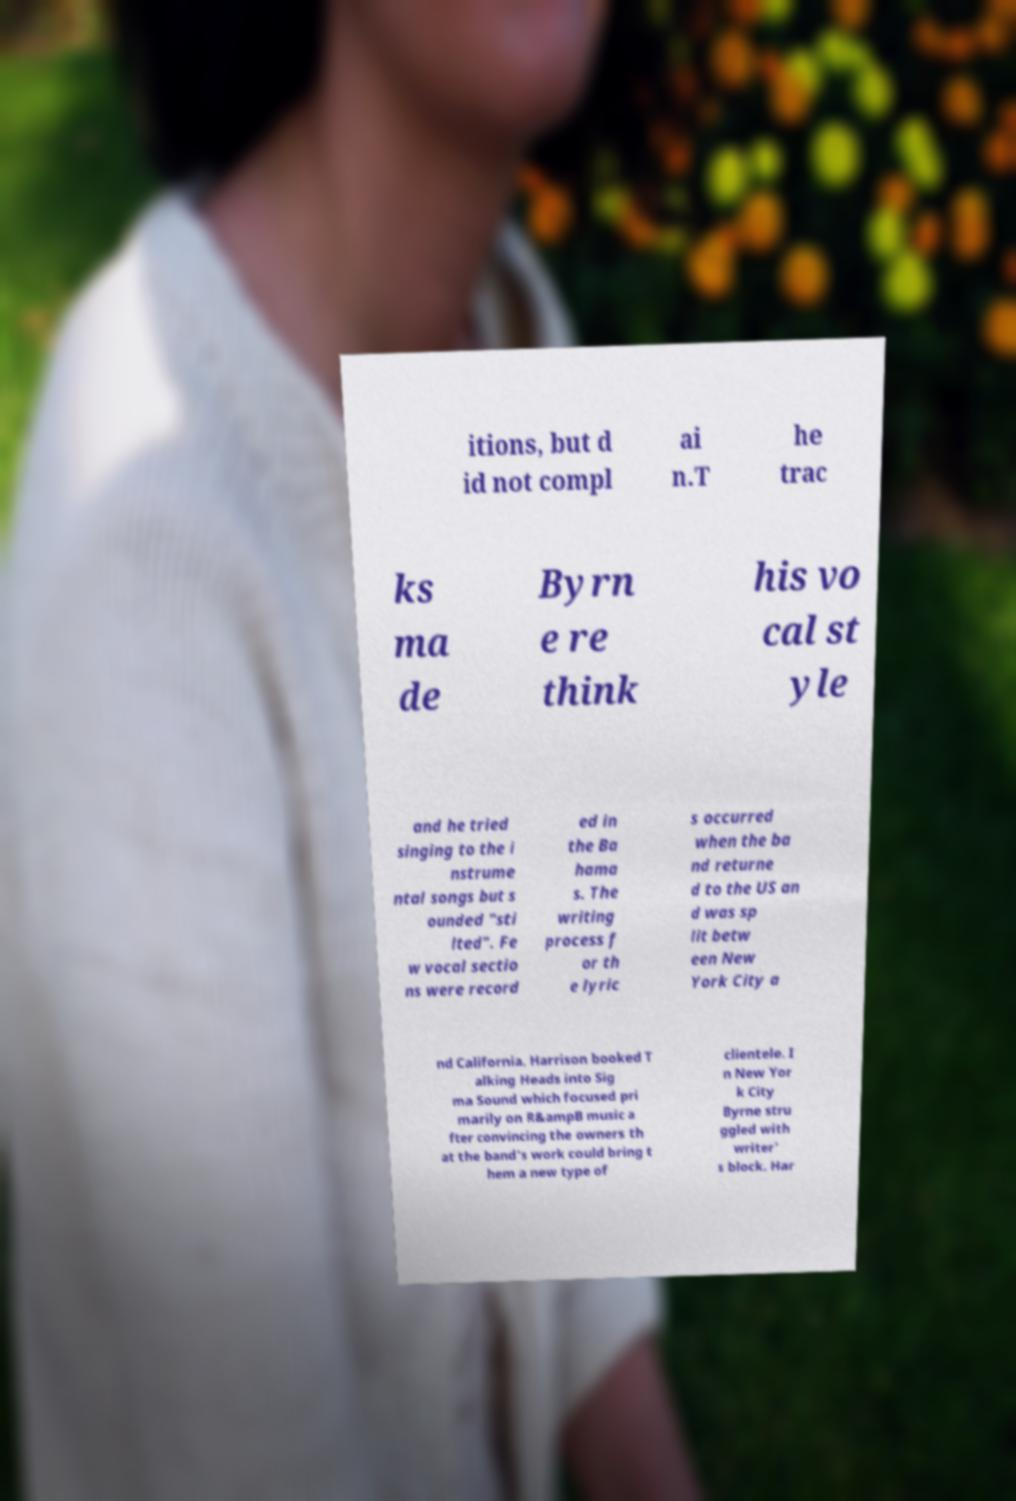Please read and relay the text visible in this image. What does it say? itions, but d id not compl ai n.T he trac ks ma de Byrn e re think his vo cal st yle and he tried singing to the i nstrume ntal songs but s ounded "sti lted". Fe w vocal sectio ns were record ed in the Ba hama s. The writing process f or th e lyric s occurred when the ba nd returne d to the US an d was sp lit betw een New York City a nd California. Harrison booked T alking Heads into Sig ma Sound which focused pri marily on R&ampB music a fter convincing the owners th at the band's work could bring t hem a new type of clientele. I n New Yor k City Byrne stru ggled with writer' s block. Har 